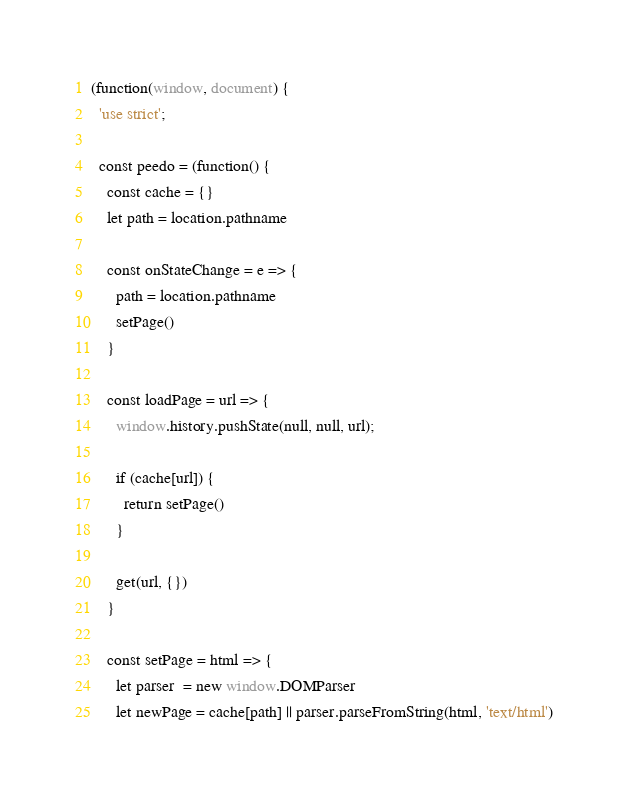Convert code to text. <code><loc_0><loc_0><loc_500><loc_500><_JavaScript_>(function(window, document) {
  'use strict';

  const peedo = (function() {
    const cache = {}
    let path = location.pathname

    const onStateChange = e => {
      path = location.pathname
      setPage()
    }

    const loadPage = url => {
      window.history.pushState(null, null, url);

      if (cache[url]) {
        return setPage()
      }

      get(url, {})
    }
    
    const setPage = html => {
      let parser  = new window.DOMParser
      let newPage = cache[path] || parser.parseFromString(html, 'text/html')
</code> 